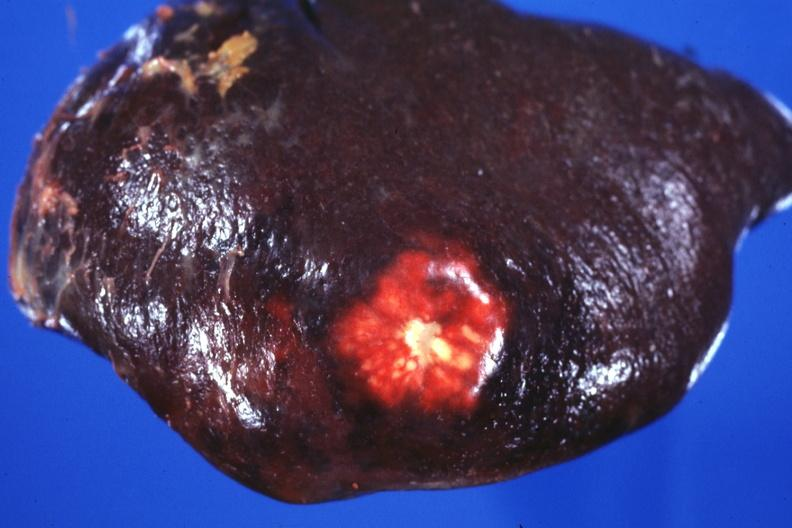what is present?
Answer the question using a single word or phrase. Hematologic 